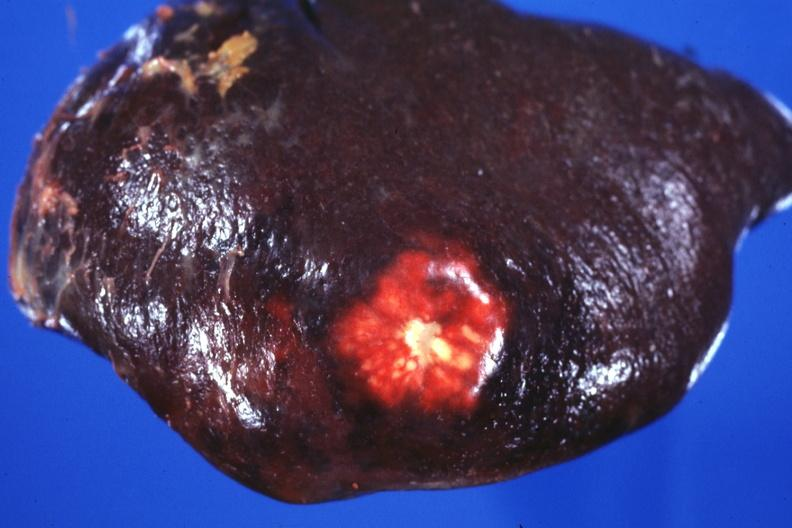what is present?
Answer the question using a single word or phrase. Hematologic 